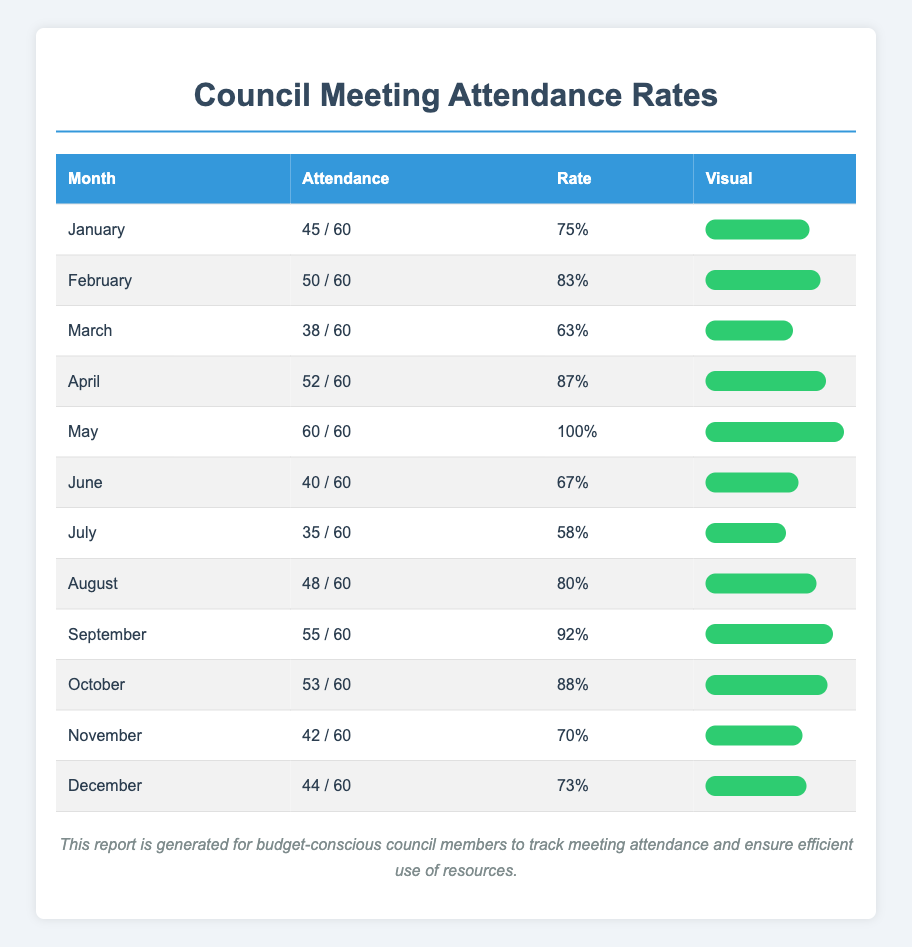What is the attendance rate for March? The attendance count for March is 38 and the total invitations are 60. To find the attendance rate, we use the formula (attendance count / total invitations) * 100. So, (38 / 60) * 100 = 63%.
Answer: 63% Which month had the highest attendance count? By examining the attendance count for each month, May has the highest attendance at 60.
Answer: May What is the average attendance rate for the first half of the year (January to June)? To find the average, we first calculate the attendance rates for the first six months: January (75%), February (83%), March (63%), April (87%), May (100%), and June (67%). Adding these values gives us 75 + 83 + 63 + 87 + 100 + 67 = 575. We then divide by the number of months, which is 6. So, 575 / 6 = 95.83.
Answer: 95.83% Is the attendance rate higher in the second half of the year compared to the first half? The total average attendance rates for the first half (January to June) is approximately 75%. The second half (July to December) has the following rates: July (58%), August (80%), September (92%), October (88%), November (70%), December (73%). The average for the second half is (58 + 80 + 92 + 88 + 70 + 73) / 6 = 76.17%. Therefore, the second half has a lower average attendance rate than the first half.
Answer: No What was the attendance count in September, and how does it compare to the count in April? The attendance count in September is 55 and in April it is 52. Comparing these, September's attendance is higher than April's by 3.
Answer: 55, higher by 3 What percentage of meetings had an attendance rate above 80%? The months with attendance rates above 80% are February (83%), April (87%), May (100%), September (92%), and October (88%). This is a total of 5 months out of 12. To find the percentage, we calculate (5 / 12) * 100 = 41.67%.
Answer: 41.67% Which month has the lowest attendance count, and what was the corresponding rate? The lowest attendance count is in July with 35 attendees. The corresponding attendance rate is (35 / 60) * 100 = 58%.
Answer: July, 58% Are there any months where attendance was at or below 70%? The months with attendance rates at or below 70% are March (63%), June (67%), and July (58%). Therefore, there are multiple months with such attendance.
Answer: Yes 